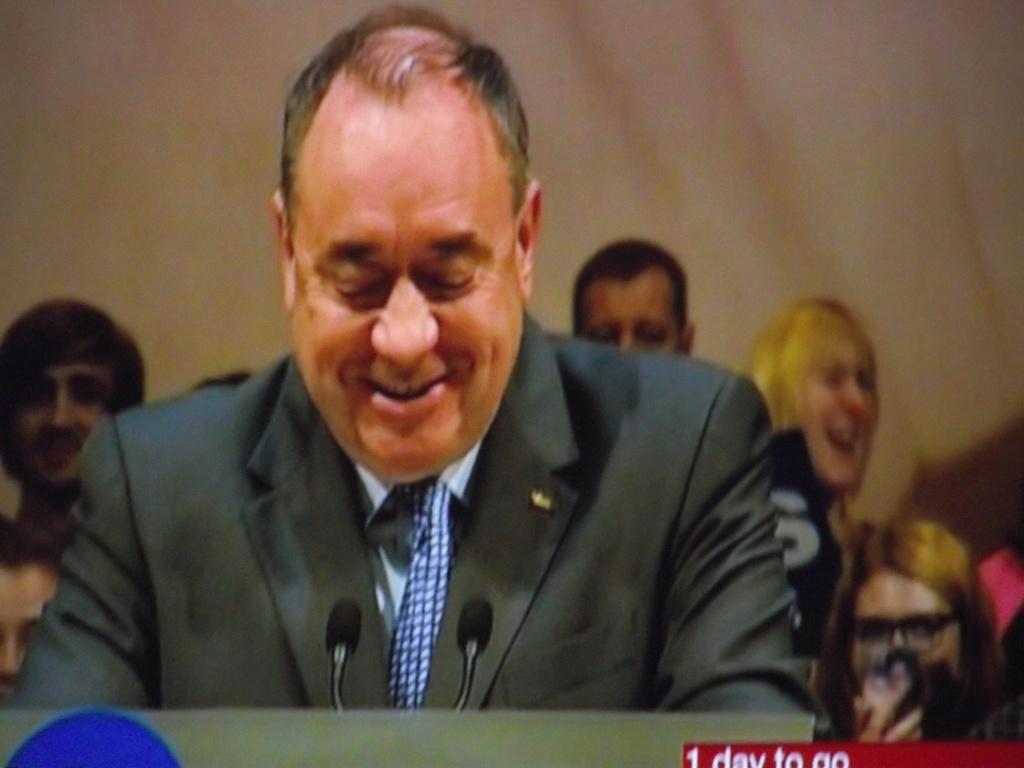In one or two sentences, can you explain what this image depicts? In the center of this picture we can see a person wearing suit, smiling and in the foreground we can see the microphones and a podium. In the background we can see the group of people and some other objects. In the bottom right corner we can see the text and number on the image. 